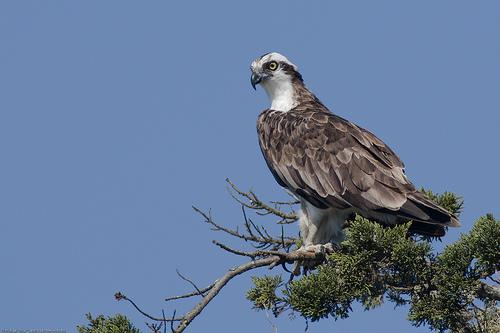Question: what is the animal?
Choices:
A. Dog.
B. Bird.
C. Cow.
D. Lion.
Answer with the letter. Answer: B 